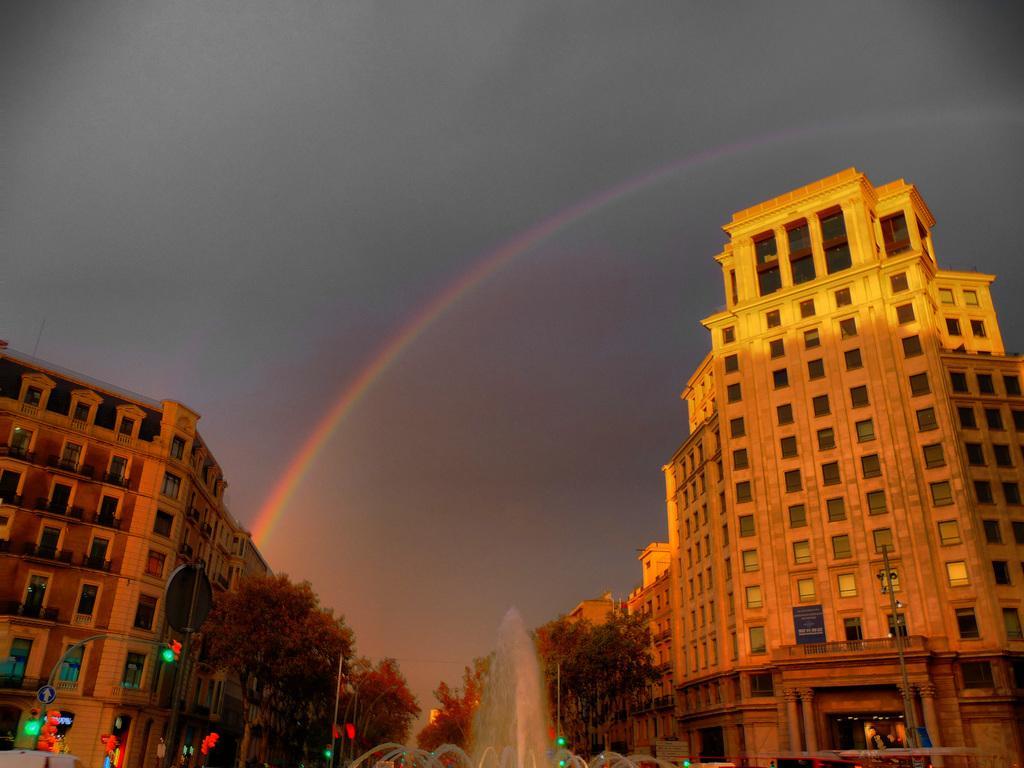In one or two sentences, can you explain what this image depicts? This picture shows few buildings and we see trees and a water fountain and few lights and a electrical pole and we see a rainbow and a cloudy Sky. 